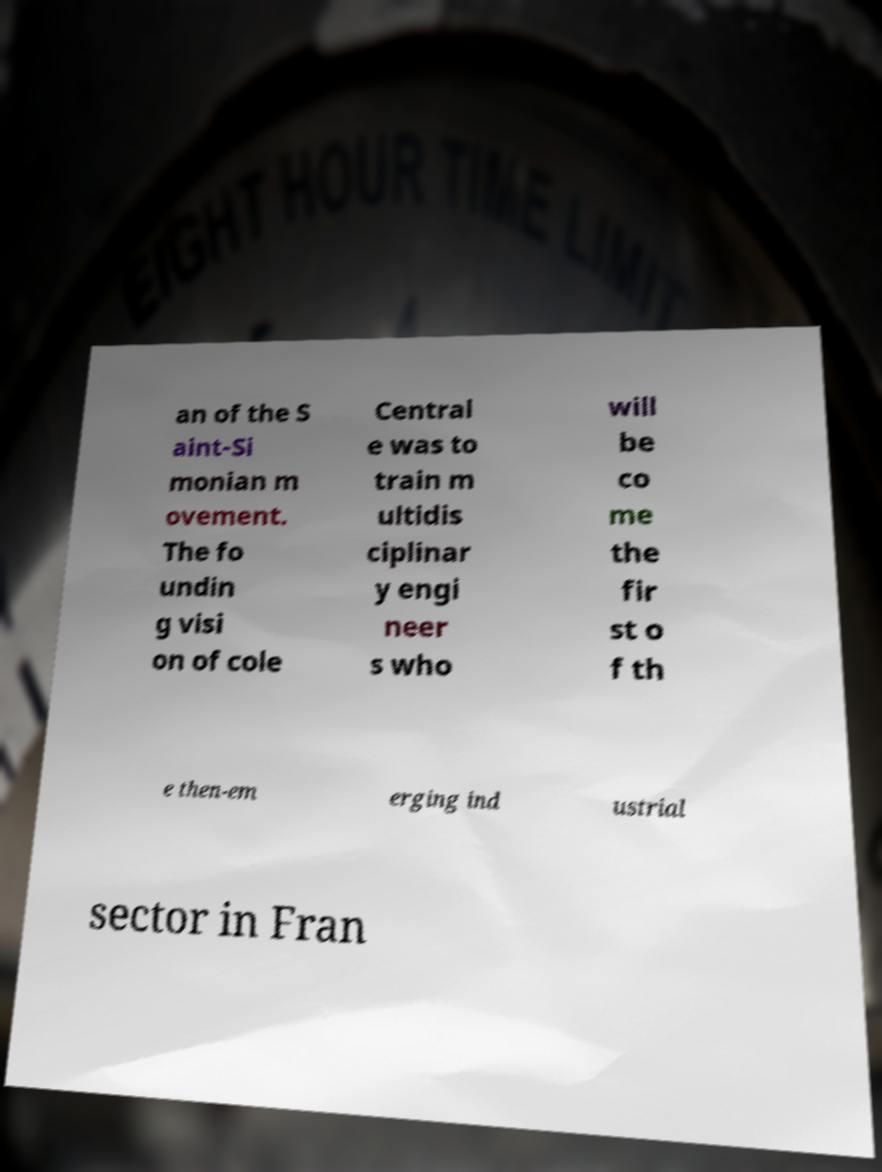Please identify and transcribe the text found in this image. an of the S aint-Si monian m ovement. The fo undin g visi on of cole Central e was to train m ultidis ciplinar y engi neer s who will be co me the fir st o f th e then-em erging ind ustrial sector in Fran 